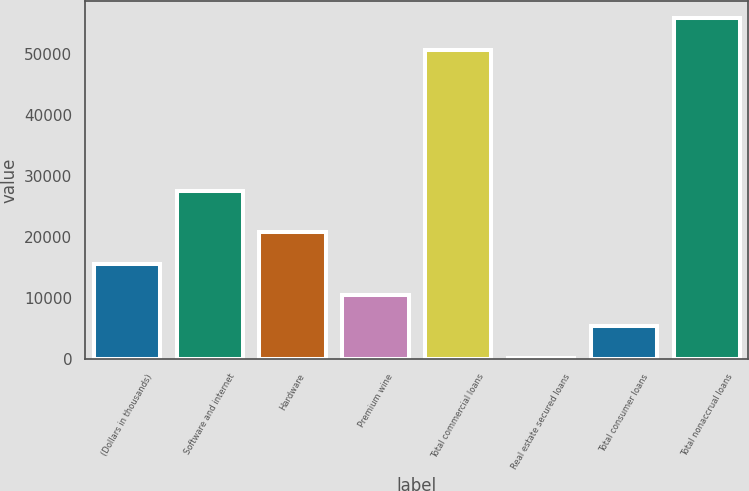Convert chart to OTSL. <chart><loc_0><loc_0><loc_500><loc_500><bar_chart><fcel>(Dollars in thousands)<fcel>Software and internet<fcel>Hardware<fcel>Premium wine<fcel>Total commercial loans<fcel>Real estate secured loans<fcel>Total consumer loans<fcel>Total nonaccrual loans<nl><fcel>15665.5<fcel>27618<fcel>20806<fcel>10525<fcel>50735<fcel>244<fcel>5384.5<fcel>55875.5<nl></chart> 